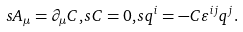<formula> <loc_0><loc_0><loc_500><loc_500>s A _ { \mu } = \partial _ { \mu } C , s C = 0 , s q ^ { i } = - C \varepsilon ^ { i j } q ^ { j } .</formula> 